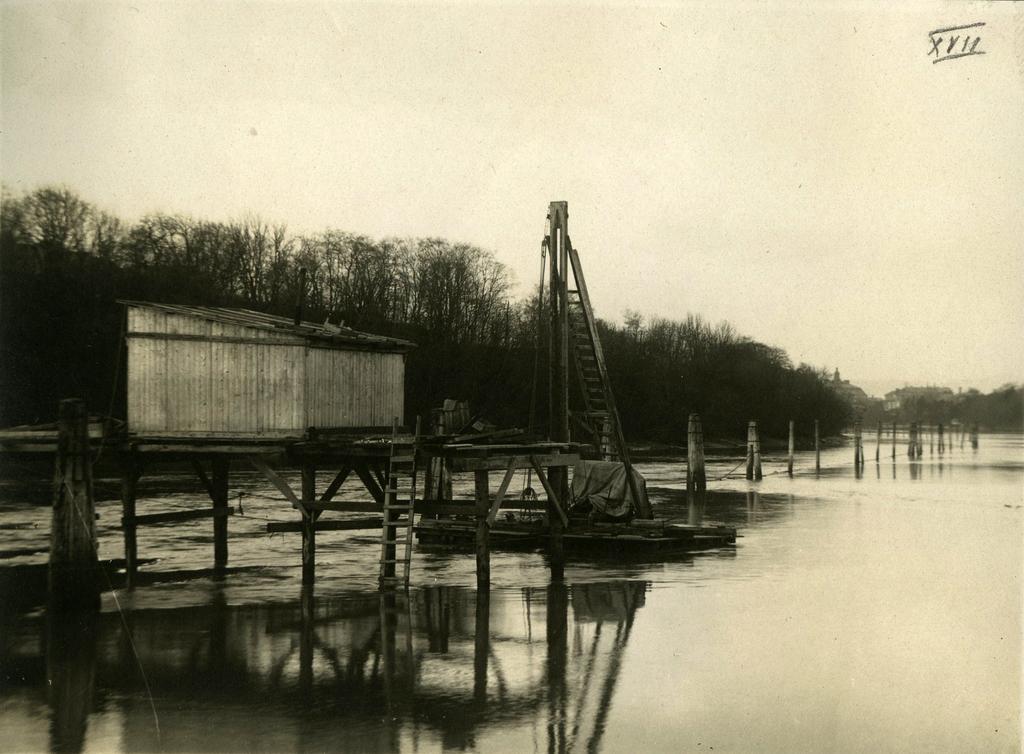Could you give a brief overview of what you see in this image? This is a black and white image. In this image we can see trees, shed, wooden ladder, water, wooden fence, trees and sky. 